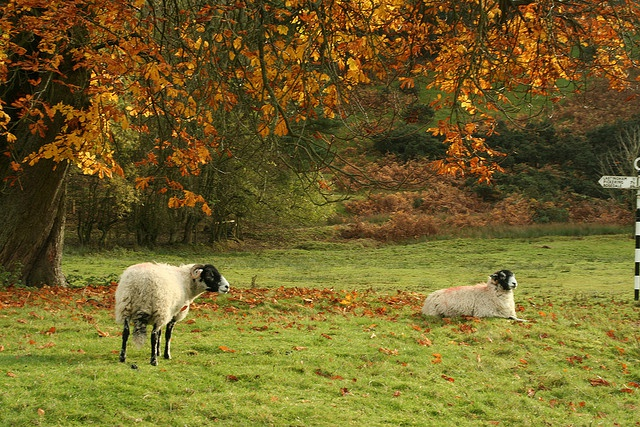Describe the objects in this image and their specific colors. I can see sheep in black, tan, and olive tones and sheep in black and tan tones in this image. 